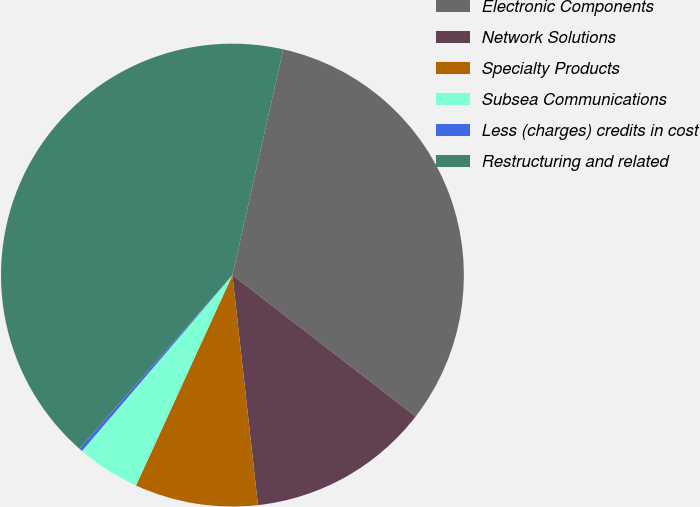Convert chart to OTSL. <chart><loc_0><loc_0><loc_500><loc_500><pie_chart><fcel>Electronic Components<fcel>Network Solutions<fcel>Specialty Products<fcel>Subsea Communications<fcel>Less (charges) credits in cost<fcel>Restructuring and related<nl><fcel>31.94%<fcel>12.78%<fcel>8.6%<fcel>4.42%<fcel>0.24%<fcel>42.03%<nl></chart> 